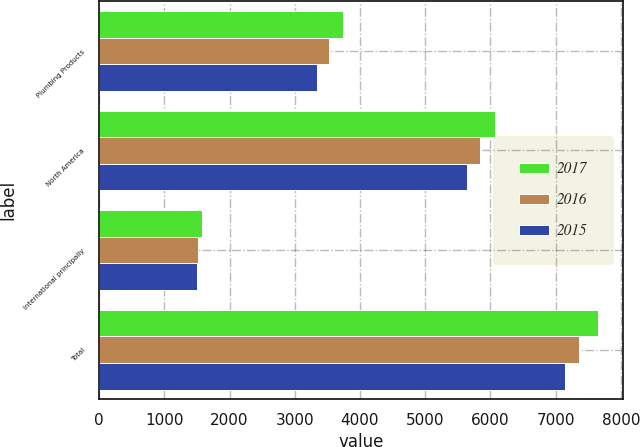Convert chart. <chart><loc_0><loc_0><loc_500><loc_500><stacked_bar_chart><ecel><fcel>Plumbing Products<fcel>North America<fcel>International principally<fcel>Total<nl><fcel>2017<fcel>3735<fcel>6069<fcel>1575<fcel>7644<nl><fcel>2016<fcel>3526<fcel>5834<fcel>1523<fcel>7357<nl><fcel>2015<fcel>3341<fcel>5645<fcel>1497<fcel>7142<nl></chart> 